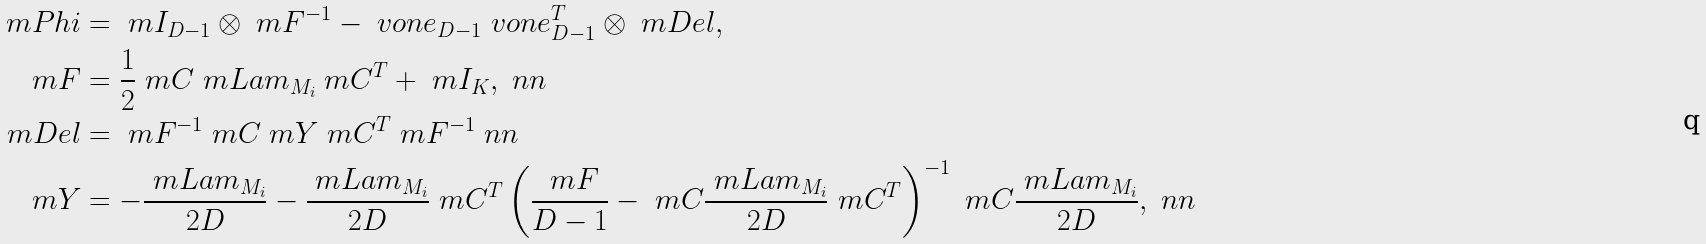Convert formula to latex. <formula><loc_0><loc_0><loc_500><loc_500>\ m P h i & = \ m I _ { D - 1 } \otimes \ m F ^ { - 1 } - \ v o n e _ { D - 1 } \ v o n e _ { D - 1 } ^ { T } \otimes \ m D e l , \\ \ m F & = \frac { 1 } { 2 } \ m C \ m L a m _ { M _ { i } } \ m C ^ { T } + \ m I _ { K } , \ n n \\ \ m D e l & = \ m F ^ { - 1 } \ m C \ m Y \ m C ^ { T } \ m F ^ { - 1 } \ n n \\ \ m Y & = - \frac { \ m L a m _ { M _ { i } } } { 2 D } - \frac { \ m L a m _ { M _ { i } } } { 2 D } \ m C ^ { T } \left ( \frac { \ m F } { D - 1 } - \ m C \frac { \ m L a m _ { M _ { i } } } { 2 D } \ m C ^ { T } \right ) ^ { - 1 } \ m C \frac { \ m L a m _ { M _ { i } } } { 2 D } , \ n n</formula> 